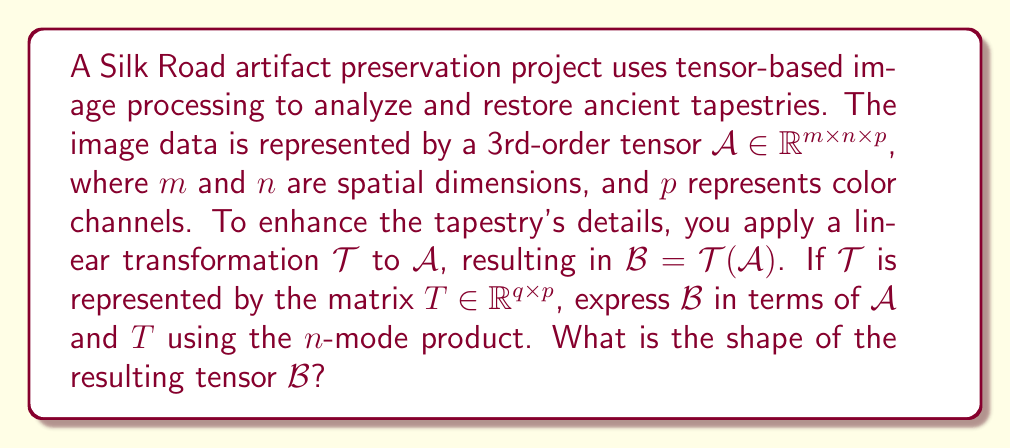Show me your answer to this math problem. To solve this problem, we need to understand the n-mode product in tensor algebra and how it applies to our image processing scenario. Let's break it down step-by-step:

1) The n-mode product of a tensor $\mathcal{A}$ with a matrix $T$ is denoted as $\mathcal{A} \times_n T$, where $n$ indicates the mode along which the product is computed.

2) In our case, we're applying the transformation to the color channels, which is the 3rd mode of our tensor $\mathcal{A}$. Therefore, we can express $\mathcal{B}$ as:

   $$\mathcal{B} = \mathcal{A} \times_3 T$$

3) The n-mode product $\mathcal{A} \times_n T$ is defined as:

   $$(\mathcal{A} \times_n T)_{i_1,\ldots,i_{n-1},j,i_{n+1},\ldots,i_N} = \sum_{i_n} \mathcal{A}_{i_1,\ldots,i_N} \cdot T_{j,i_n}$$

4) To determine the shape of $\mathcal{B}$, we need to consider how the n-mode product affects the dimensions:
   - The first two dimensions (m and n) remain unchanged.
   - The third dimension changes from p to q, as we're multiplying by a matrix $T \in \mathbb{R}^{q \times p}$.

5) Therefore, the resulting tensor $\mathcal{B}$ will have the shape $m \times n \times q$.
Answer: $\mathcal{B} = \mathcal{A} \times_3 T$, with shape $m \times n \times q$ 